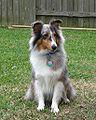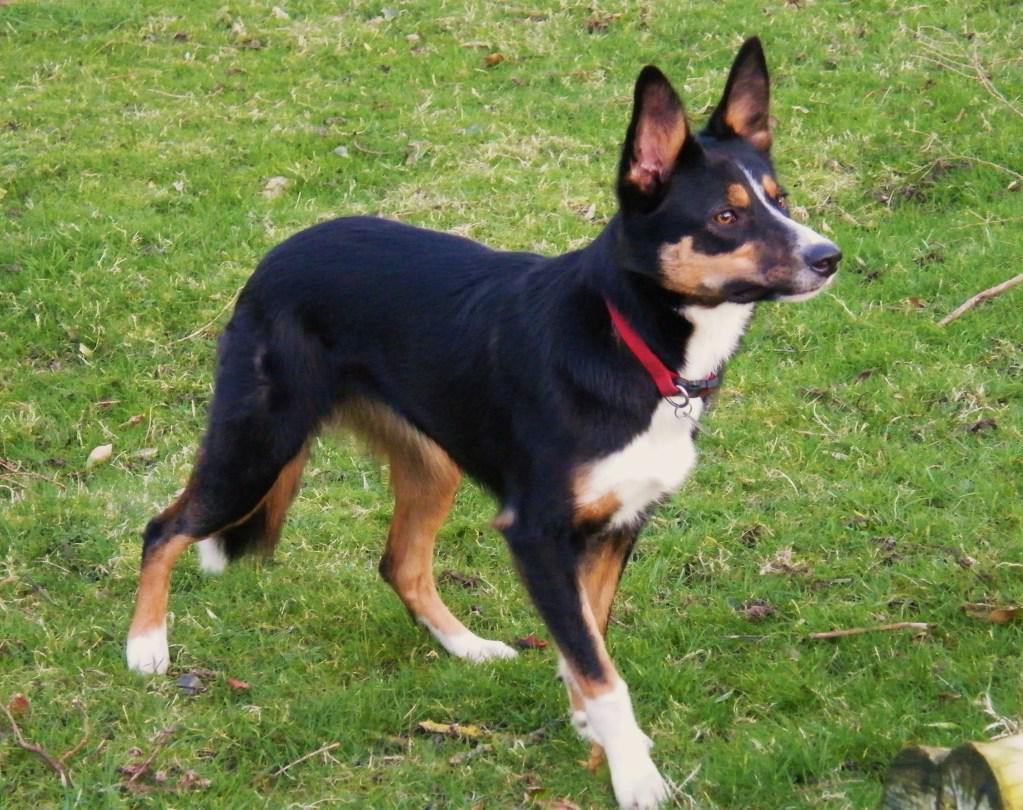The first image is the image on the left, the second image is the image on the right. Assess this claim about the two images: "Right image shows a dog standing on grass, with its body turned rightward.". Correct or not? Answer yes or no. Yes. The first image is the image on the left, the second image is the image on the right. For the images shown, is this caption "In one of the images there is a dog standing in the grass and looking away from the camera." true? Answer yes or no. Yes. 